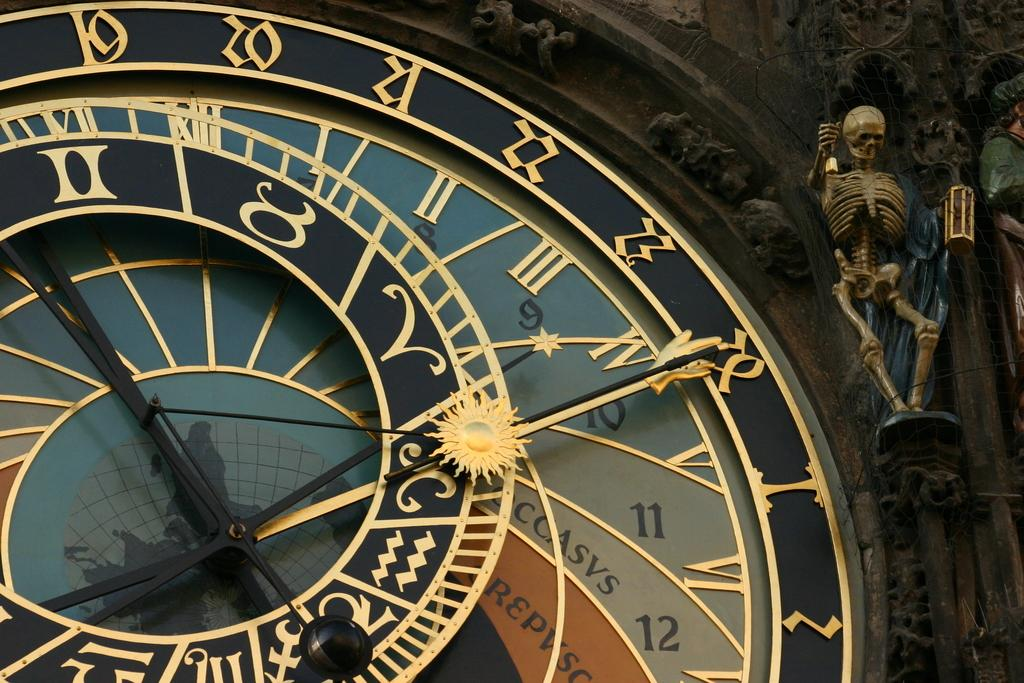<image>
Present a compact description of the photo's key features. "CCASVS" are some letters shown on a clock face. 